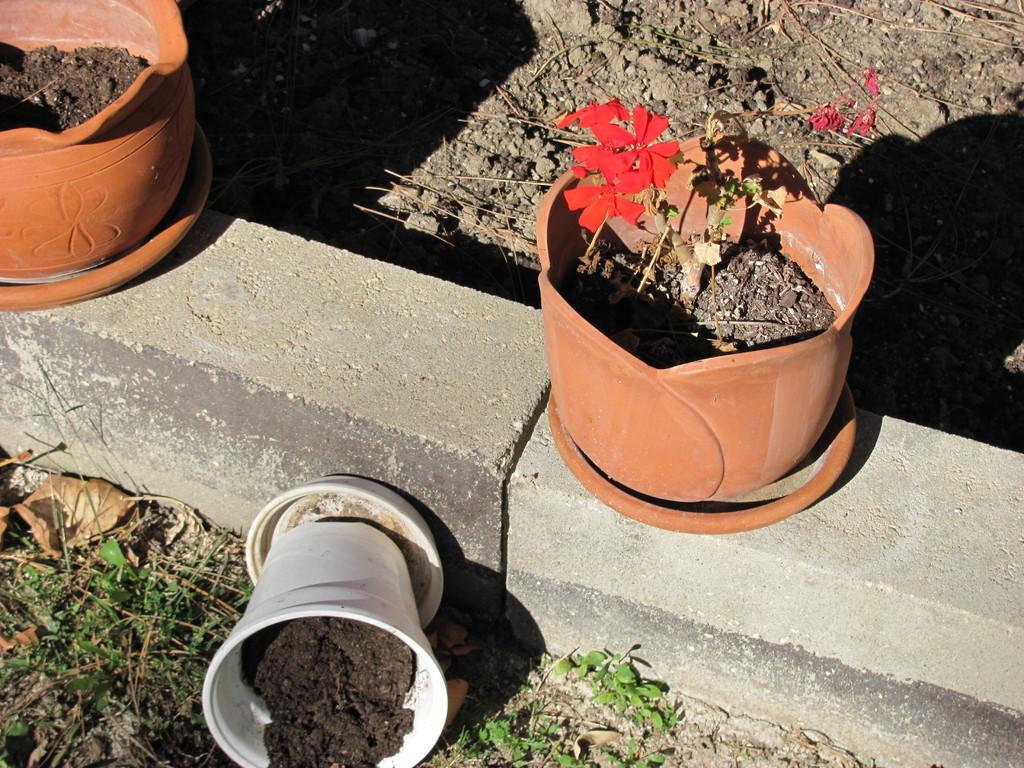What type of vegetation is present in the image? There is grass in the image. What other objects can be seen in the image? There are stones and plant pots on plates with mud and flowers in the image. What is the condition of the stocks in the background? In the background, there are stocks on the ground. What type of nose can be seen on the calendar in the image? There is no calendar present in the image, and therefore no nose can be seen. 